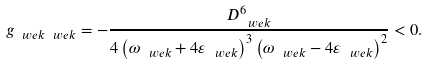Convert formula to latex. <formula><loc_0><loc_0><loc_500><loc_500>g _ { \ w e { k } \ w e { k } } = - \frac { D _ { \ w e { k } } ^ { 6 } } { 4 \left ( \omega _ { \ w e { k } } + 4 \varepsilon _ { \ w e { k } } \right ) ^ { 3 } \left ( \omega _ { \ w e { k } } - 4 \varepsilon _ { \ w e { k } } \right ) ^ { 2 } } < 0 .</formula> 